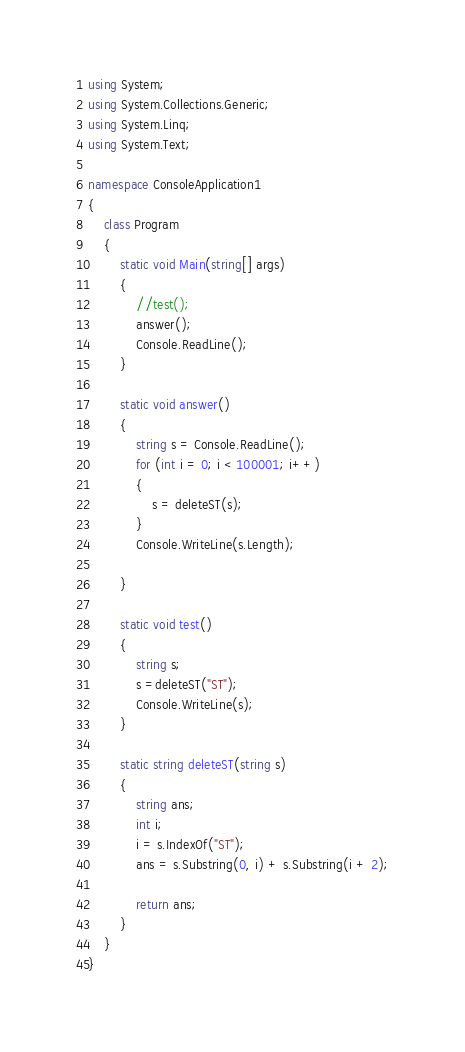Convert code to text. <code><loc_0><loc_0><loc_500><loc_500><_C#_>using System;
using System.Collections.Generic;
using System.Linq;
using System.Text;

namespace ConsoleApplication1
{
    class Program
    {
        static void Main(string[] args)
        {
            //test();
            answer();
            Console.ReadLine();
        }

        static void answer()
        {
            string s = Console.ReadLine();
            for (int i = 0; i < 100001; i++)
            {
                s = deleteST(s);
            }
            Console.WriteLine(s.Length);

        }

        static void test()
        {
            string s;
            s =deleteST("ST");
            Console.WriteLine(s);
        }

        static string deleteST(string s)
        {
            string ans;
            int i;
            i = s.IndexOf("ST");
            ans = s.Substring(0, i) + s.Substring(i + 2);

            return ans;
        }
    }
}
</code> 